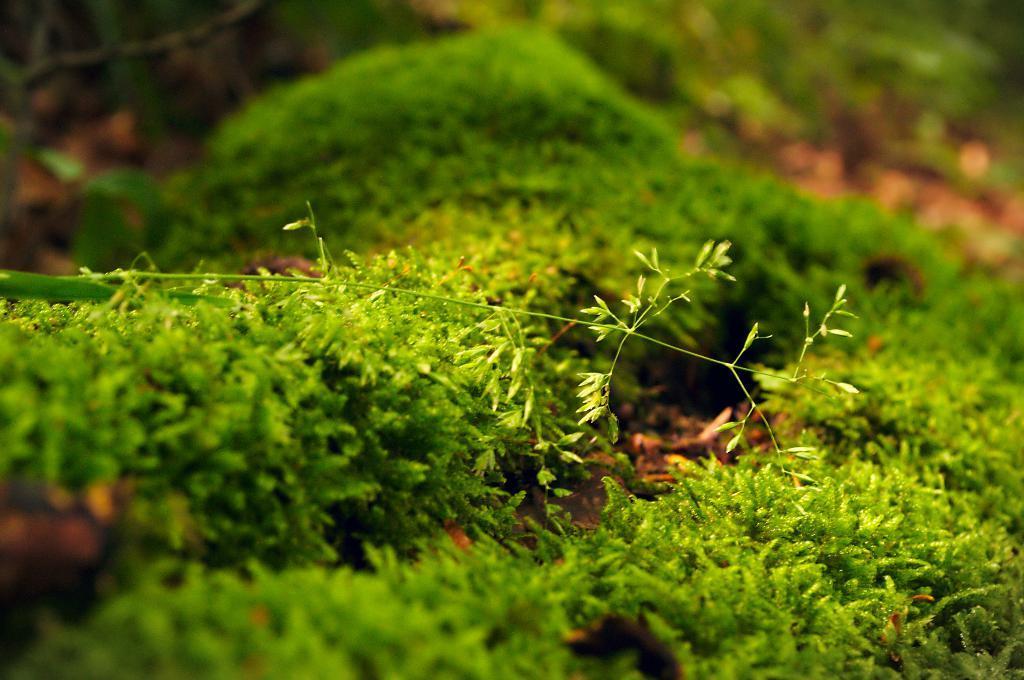Can you describe this image briefly? In the center of the image there is grass. 